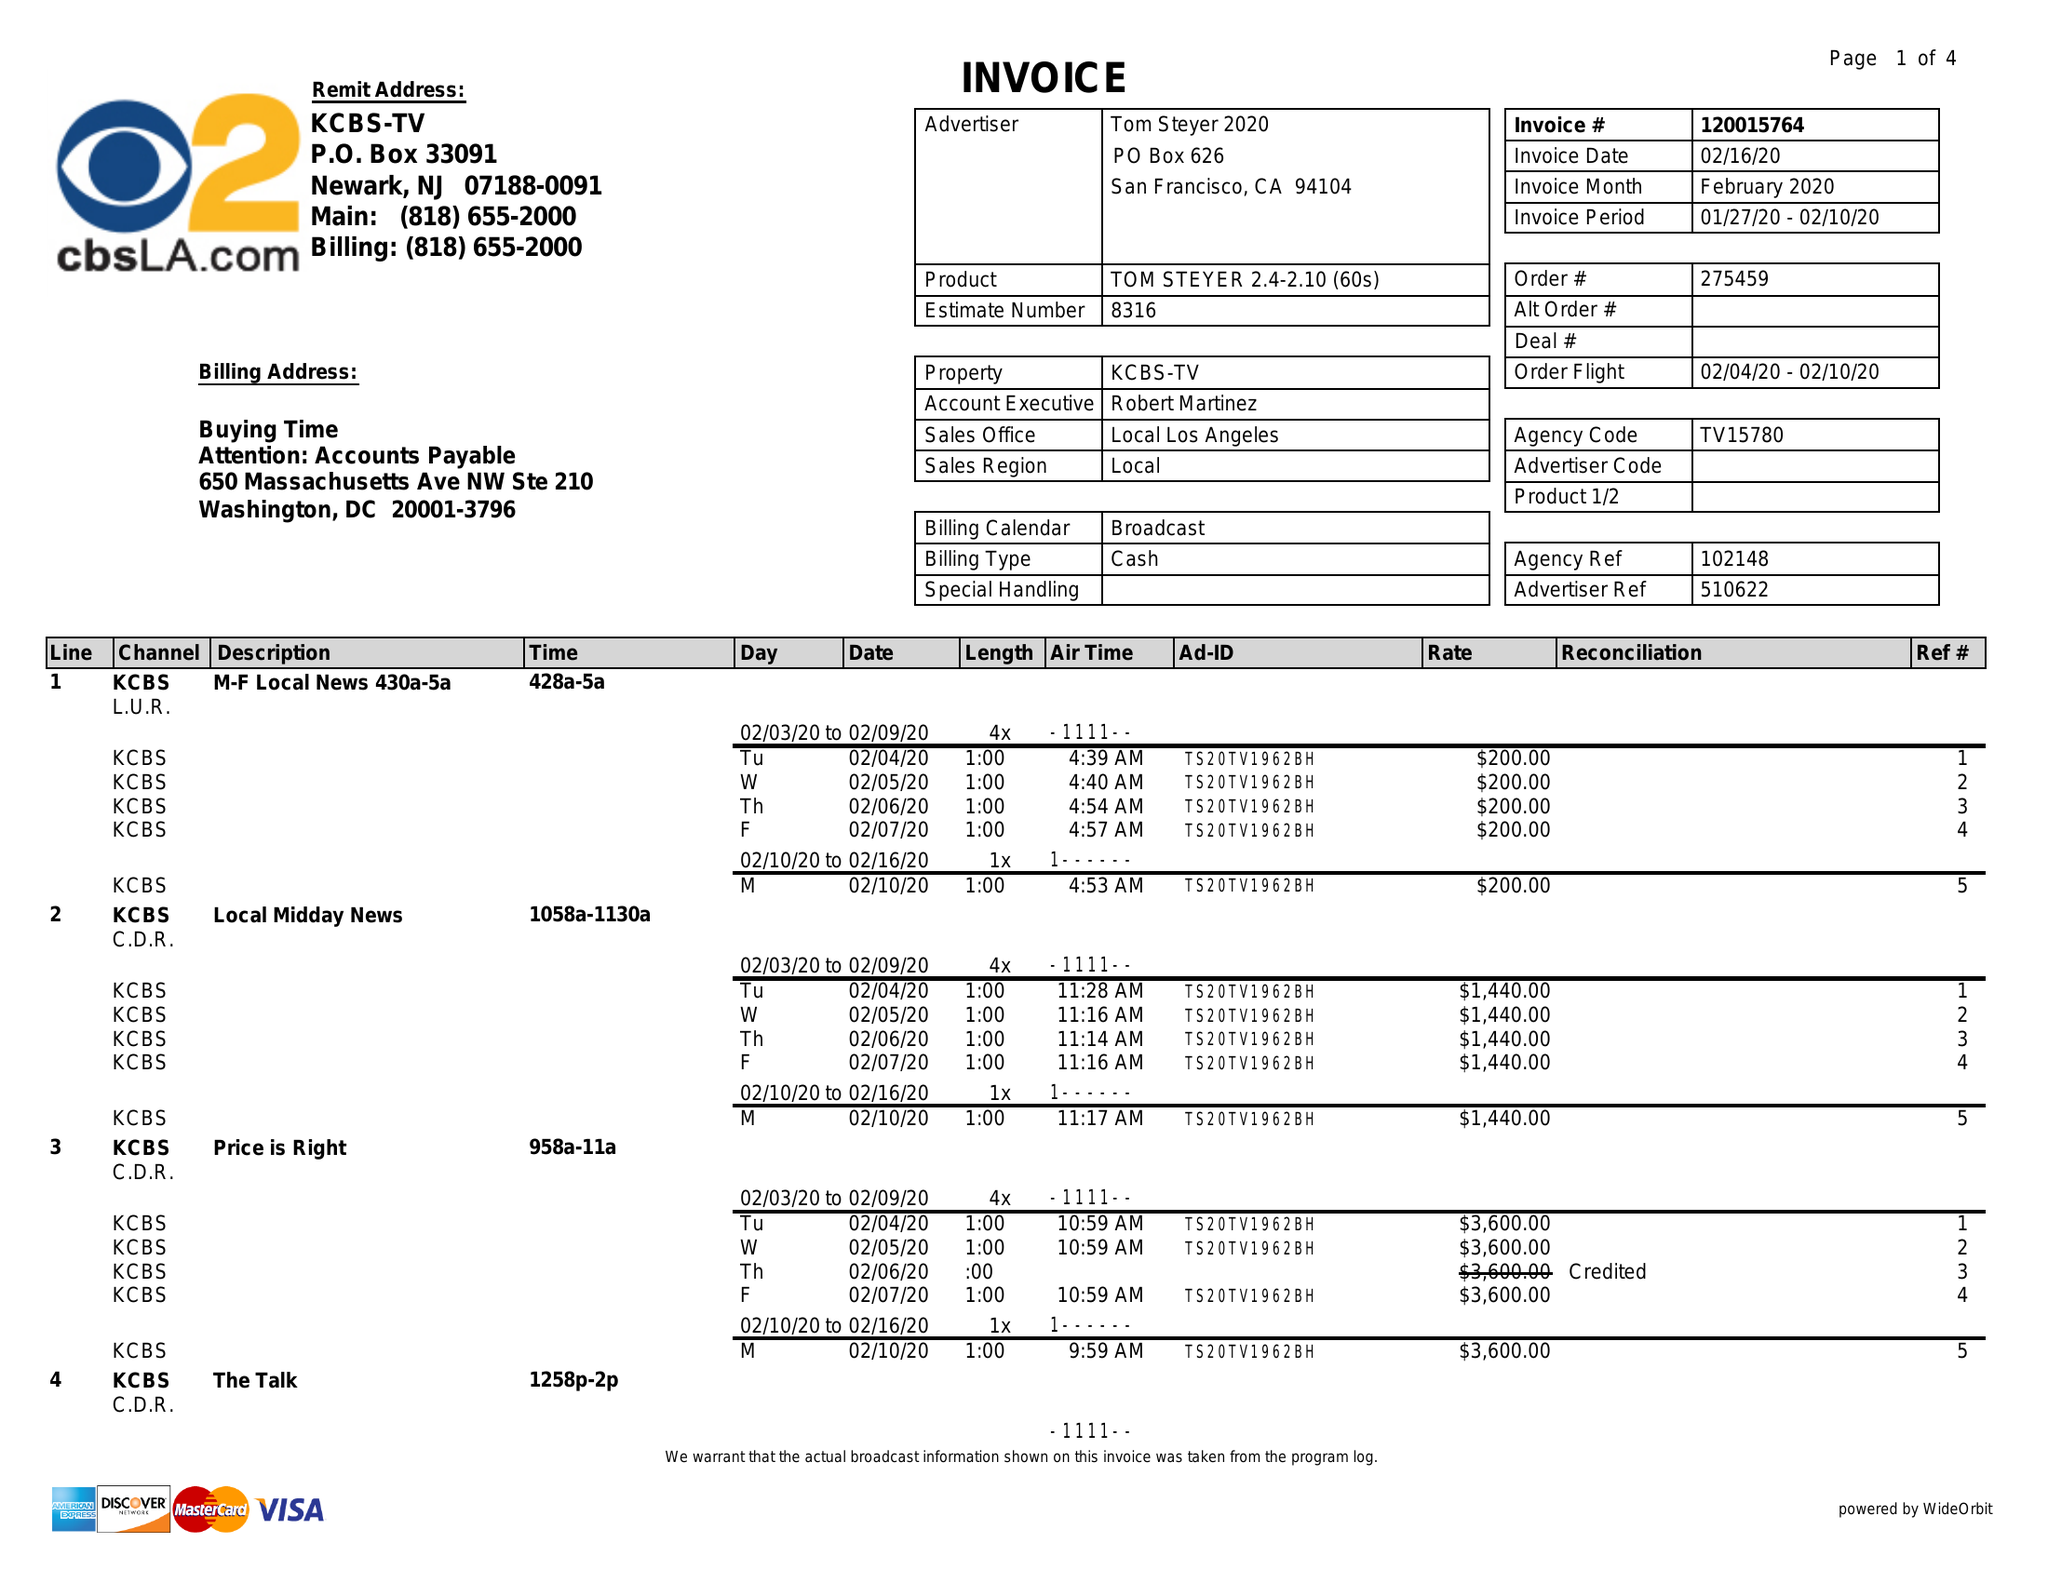What is the value for the gross_amount?
Answer the question using a single word or phrase. 90920.00 